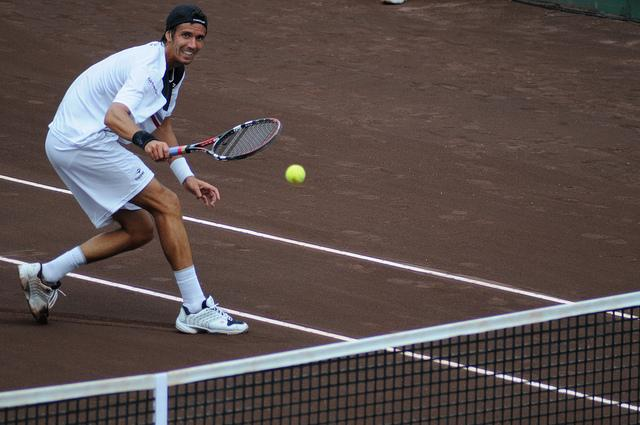How is the tennis player feeling? Please explain your reasoning. happy. The person is happy. 